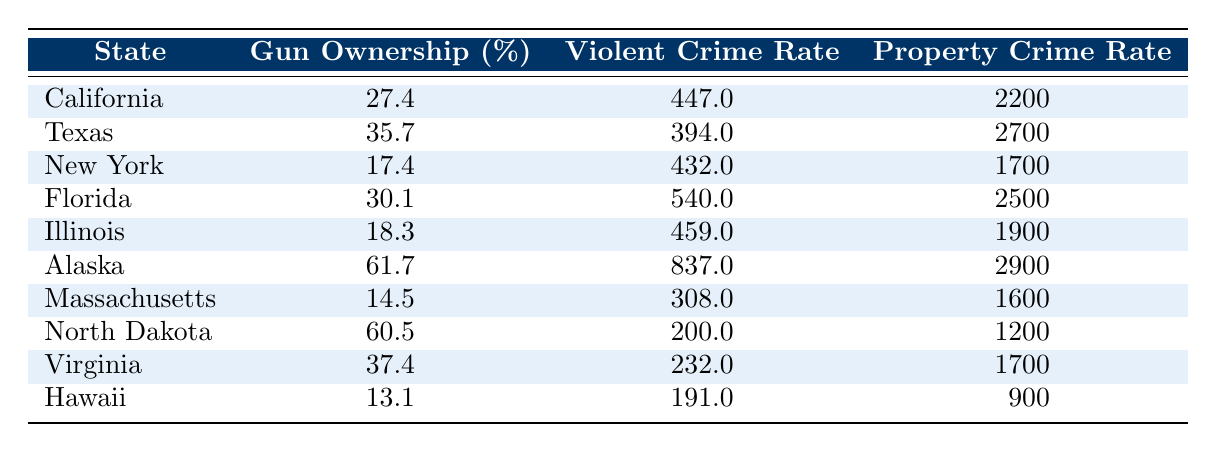What is the gun ownership rate in California? The table lists California under the "State" column, and in the "Gun Ownership (%)" column, California has a value of 27.4.
Answer: 27.4 Which state has the highest violent crime rate? By examining the "Violent Crime Rate" column, Alaska is listed with a violent crime rate of 837.0, which is higher than all other states in the table.
Answer: Alaska Is the violent crime rate higher in Texas or Florida? Texas has a violent crime rate of 394.0 and Florida has a violent crime rate of 540.0. Comparing these values, Florida has the higher rate.
Answer: Florida What is the difference between the property crime rates of California and Virginia? The property crime rate for California is 2200.0 and for Virginia, it is 1700.0. The difference is calculated by subtracting Virginia's rate from California's: 2200.0 - 1700.0 = 500.0.
Answer: 500.0 What is the average gun ownership rate for the states listed in the table? First, we sum up all the gun ownership rates: (27.4 + 35.7 + 17.4 + 30.1 + 18.3 + 61.7 + 14.5 + 60.5 + 37.4 + 13.1) = 305.7. There are 10 states, so we find the average: 305.7 / 10 = 30.57.
Answer: 30.57 Is Massachusetts among the states with a gun ownership rate higher than 20%? Massachusetts has a gun ownership rate of 14.5%, which is lower than 20%. Therefore, it is not among those states.
Answer: No Which state has the lowest property crime rate? The table shows that Hawaii has the lowest property crime rate at 900.0, compared to all other states listed.
Answer: Hawaii Which state has a higher gun ownership rate: North Dakota or Alaska? North Dakota has a gun ownership rate of 60.5, while Alaska has a higher rate of 61.7. Thus, Alaska has the higher gun ownership rate.
Answer: Alaska 